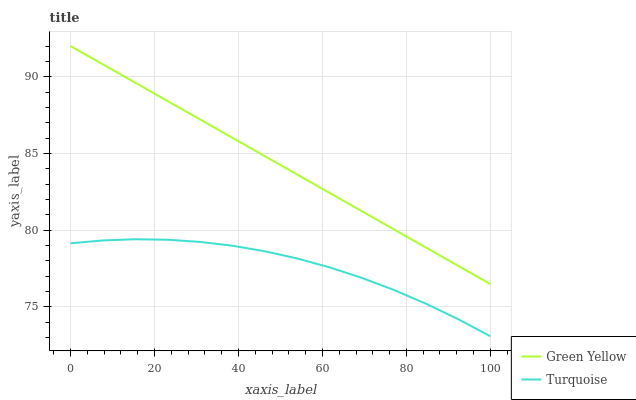Does Turquoise have the minimum area under the curve?
Answer yes or no. Yes. Does Green Yellow have the maximum area under the curve?
Answer yes or no. Yes. Does Green Yellow have the minimum area under the curve?
Answer yes or no. No. Is Green Yellow the smoothest?
Answer yes or no. Yes. Is Turquoise the roughest?
Answer yes or no. Yes. Is Green Yellow the roughest?
Answer yes or no. No. Does Turquoise have the lowest value?
Answer yes or no. Yes. Does Green Yellow have the lowest value?
Answer yes or no. No. Does Green Yellow have the highest value?
Answer yes or no. Yes. Is Turquoise less than Green Yellow?
Answer yes or no. Yes. Is Green Yellow greater than Turquoise?
Answer yes or no. Yes. Does Turquoise intersect Green Yellow?
Answer yes or no. No. 